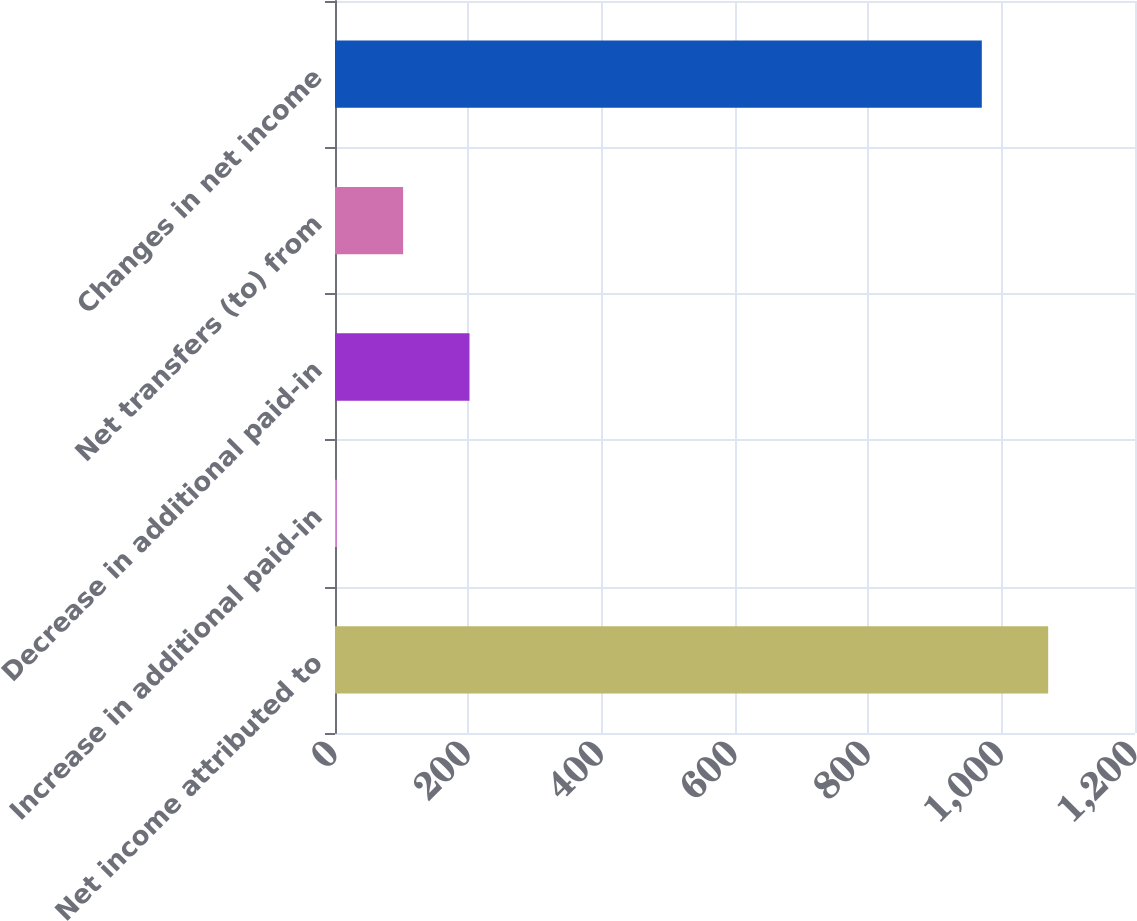Convert chart. <chart><loc_0><loc_0><loc_500><loc_500><bar_chart><fcel>Net income attributed to<fcel>Increase in additional paid-in<fcel>Decrease in additional paid-in<fcel>Net transfers (to) from<fcel>Changes in net income<nl><fcel>1069.77<fcel>2.6<fcel>201.74<fcel>102.17<fcel>970.2<nl></chart> 